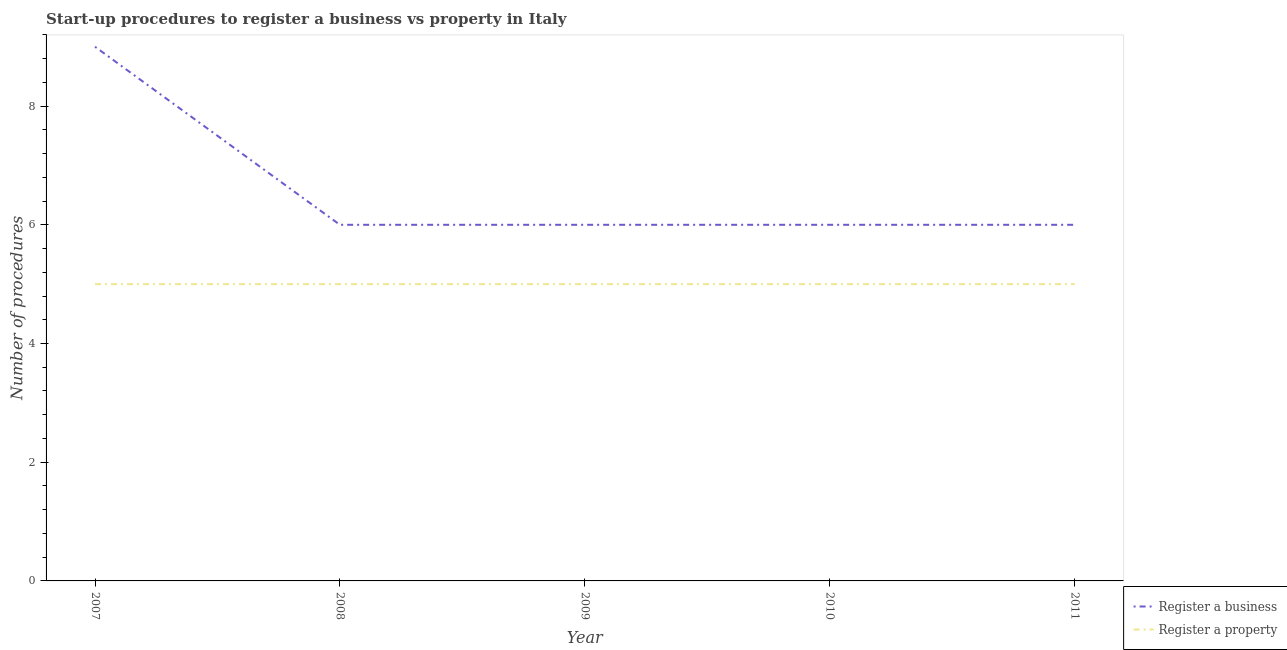What is the number of procedures to register a property in 2010?
Offer a very short reply. 5. Across all years, what is the maximum number of procedures to register a property?
Your answer should be very brief. 5. Across all years, what is the minimum number of procedures to register a property?
Your response must be concise. 5. In which year was the number of procedures to register a property maximum?
Provide a short and direct response. 2007. What is the total number of procedures to register a business in the graph?
Keep it short and to the point. 33. What is the difference between the number of procedures to register a property in 2007 and that in 2010?
Your answer should be compact. 0. What is the difference between the number of procedures to register a property in 2007 and the number of procedures to register a business in 2010?
Make the answer very short. -1. In the year 2010, what is the difference between the number of procedures to register a property and number of procedures to register a business?
Your response must be concise. -1. Does the number of procedures to register a business monotonically increase over the years?
Your answer should be very brief. No. Where does the legend appear in the graph?
Provide a succinct answer. Bottom right. How many legend labels are there?
Keep it short and to the point. 2. What is the title of the graph?
Make the answer very short. Start-up procedures to register a business vs property in Italy. Does "GDP at market prices" appear as one of the legend labels in the graph?
Make the answer very short. No. What is the label or title of the Y-axis?
Offer a terse response. Number of procedures. What is the Number of procedures in Register a property in 2007?
Keep it short and to the point. 5. What is the Number of procedures in Register a business in 2008?
Make the answer very short. 6. What is the Number of procedures of Register a property in 2008?
Your answer should be compact. 5. What is the Number of procedures of Register a business in 2010?
Provide a succinct answer. 6. What is the Number of procedures of Register a property in 2010?
Your answer should be compact. 5. What is the Number of procedures in Register a business in 2011?
Give a very brief answer. 6. Across all years, what is the maximum Number of procedures in Register a business?
Provide a short and direct response. 9. Across all years, what is the maximum Number of procedures in Register a property?
Ensure brevity in your answer.  5. Across all years, what is the minimum Number of procedures in Register a business?
Keep it short and to the point. 6. Across all years, what is the minimum Number of procedures in Register a property?
Provide a short and direct response. 5. What is the difference between the Number of procedures of Register a business in 2007 and that in 2008?
Offer a terse response. 3. What is the difference between the Number of procedures in Register a property in 2007 and that in 2008?
Give a very brief answer. 0. What is the difference between the Number of procedures of Register a business in 2007 and that in 2009?
Make the answer very short. 3. What is the difference between the Number of procedures of Register a business in 2007 and that in 2010?
Offer a terse response. 3. What is the difference between the Number of procedures of Register a property in 2007 and that in 2010?
Your answer should be compact. 0. What is the difference between the Number of procedures in Register a business in 2007 and that in 2011?
Provide a succinct answer. 3. What is the difference between the Number of procedures of Register a property in 2007 and that in 2011?
Offer a very short reply. 0. What is the difference between the Number of procedures in Register a property in 2008 and that in 2009?
Provide a succinct answer. 0. What is the difference between the Number of procedures of Register a business in 2008 and that in 2011?
Provide a succinct answer. 0. What is the difference between the Number of procedures of Register a property in 2008 and that in 2011?
Give a very brief answer. 0. What is the difference between the Number of procedures of Register a property in 2009 and that in 2010?
Keep it short and to the point. 0. What is the difference between the Number of procedures in Register a property in 2009 and that in 2011?
Ensure brevity in your answer.  0. What is the difference between the Number of procedures in Register a business in 2010 and that in 2011?
Offer a terse response. 0. What is the difference between the Number of procedures in Register a business in 2007 and the Number of procedures in Register a property in 2010?
Provide a short and direct response. 4. What is the difference between the Number of procedures of Register a business in 2007 and the Number of procedures of Register a property in 2011?
Give a very brief answer. 4. What is the difference between the Number of procedures in Register a business in 2008 and the Number of procedures in Register a property in 2010?
Give a very brief answer. 1. What is the difference between the Number of procedures of Register a business in 2010 and the Number of procedures of Register a property in 2011?
Ensure brevity in your answer.  1. What is the average Number of procedures in Register a property per year?
Ensure brevity in your answer.  5. In the year 2008, what is the difference between the Number of procedures in Register a business and Number of procedures in Register a property?
Keep it short and to the point. 1. In the year 2011, what is the difference between the Number of procedures in Register a business and Number of procedures in Register a property?
Provide a succinct answer. 1. What is the ratio of the Number of procedures of Register a business in 2007 to that in 2008?
Your answer should be compact. 1.5. What is the ratio of the Number of procedures in Register a property in 2007 to that in 2008?
Offer a terse response. 1. What is the ratio of the Number of procedures in Register a business in 2007 to that in 2009?
Ensure brevity in your answer.  1.5. What is the ratio of the Number of procedures of Register a property in 2007 to that in 2010?
Your response must be concise. 1. What is the ratio of the Number of procedures in Register a business in 2007 to that in 2011?
Offer a terse response. 1.5. What is the ratio of the Number of procedures in Register a business in 2008 to that in 2010?
Your response must be concise. 1. What is the ratio of the Number of procedures of Register a business in 2010 to that in 2011?
Your response must be concise. 1. What is the ratio of the Number of procedures of Register a property in 2010 to that in 2011?
Make the answer very short. 1. What is the difference between the highest and the second highest Number of procedures of Register a business?
Offer a very short reply. 3. What is the difference between the highest and the lowest Number of procedures in Register a property?
Ensure brevity in your answer.  0. 